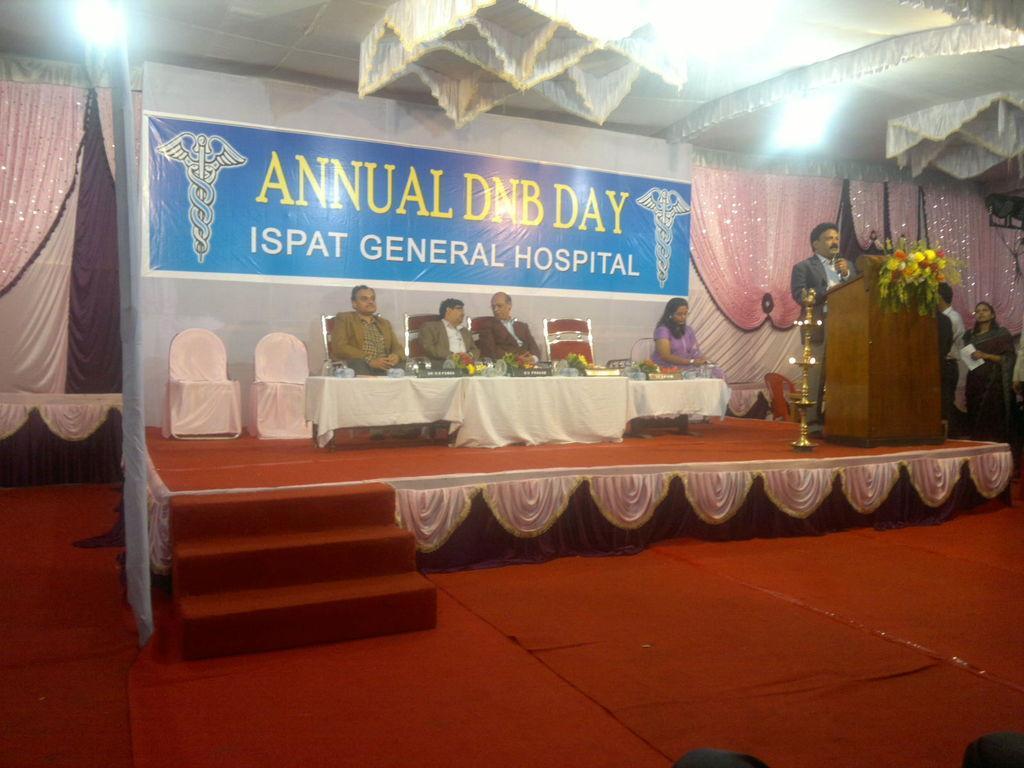Could you give a brief overview of what you see in this image? In this image there are a few people sitting on the chairs, which is on the stage and there is a table with some stuff on it, beside them there is a person standing on the bias, beside him there is a lamp. On the right side of the image there are a few people standing. In the background there are curtains and a banner. At the top of the image there is a tent. 